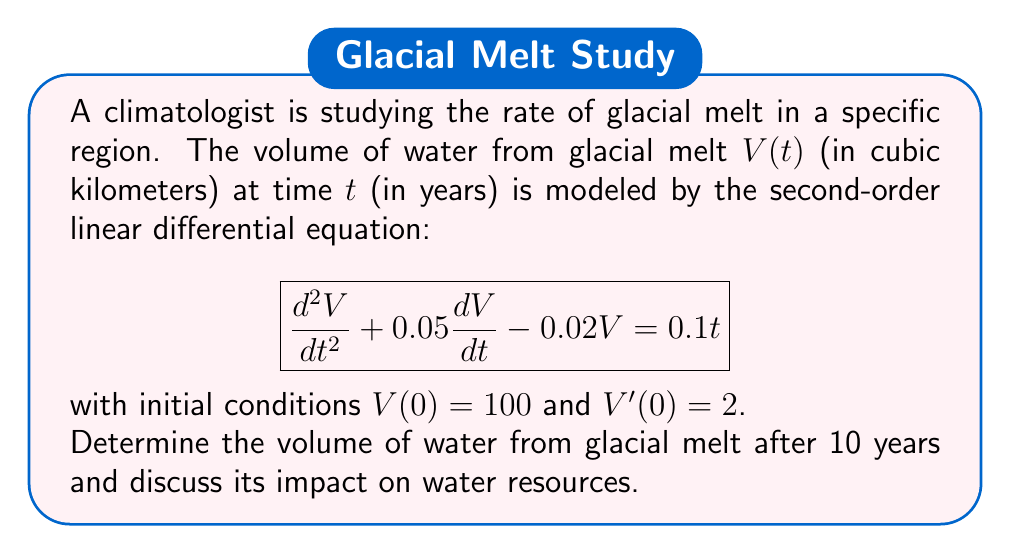Give your solution to this math problem. To solve this problem, we need to follow these steps:

1) First, we need to find the general solution to the homogeneous equation:
   $$\frac{d^2V}{dt^2} + 0.05\frac{dV}{dt} - 0.02V = 0$$

   The characteristic equation is:
   $$r^2 + 0.05r - 0.02 = 0$$

   Solving this, we get:
   $$r = \frac{-0.05 \pm \sqrt{0.05^2 + 4(0.02)}}{2} = -0.025 \pm 0.15$$

   So, $r_1 = 0.125$ and $r_2 = -0.175$

   The homogeneous solution is:
   $$V_h(t) = c_1e^{0.125t} + c_2e^{-0.175t}$$

2) Next, we need to find a particular solution. Let's try $V_p(t) = At + B$:
   
   $$A = 0.1$$
   $$-0.02B = 0$$
   $$B = 0$$

   So, $V_p(t) = 0.1t$

3) The general solution is:
   $$V(t) = c_1e^{0.125t} + c_2e^{-0.175t} + 0.1t$$

4) Now we use the initial conditions to find $c_1$ and $c_2$:
   
   $V(0) = 100$: $c_1 + c_2 = 100$
   $V'(0) = 2$: $0.125c_1 - 0.175c_2 + 0.1 = 2$

   Solving these equations:
   $c_1 \approx 66.67$ and $c_2 \approx 33.33$

5) Therefore, the particular solution is:
   $$V(t) = 66.67e^{0.125t} + 33.33e^{-0.175t} + 0.1t$$

6) To find the volume after 10 years, we calculate $V(10)$:
   $$V(10) = 66.67e^{1.25} + 33.33e^{-1.75} + 1 \approx 235.76$$

Impact on water resources:
The volume of water from glacial melt has increased from 100 km³ to approximately 235.76 km³ in 10 years. This significant increase in water volume could lead to:
- Increased risk of flooding in low-lying areas
- Potential short-term increase in freshwater availability
- Long-term concerns about water sustainability as glaciers continue to shrink
- Changes in local ecosystems and agriculture due to altered water patterns
Answer: 235.76 km³ 